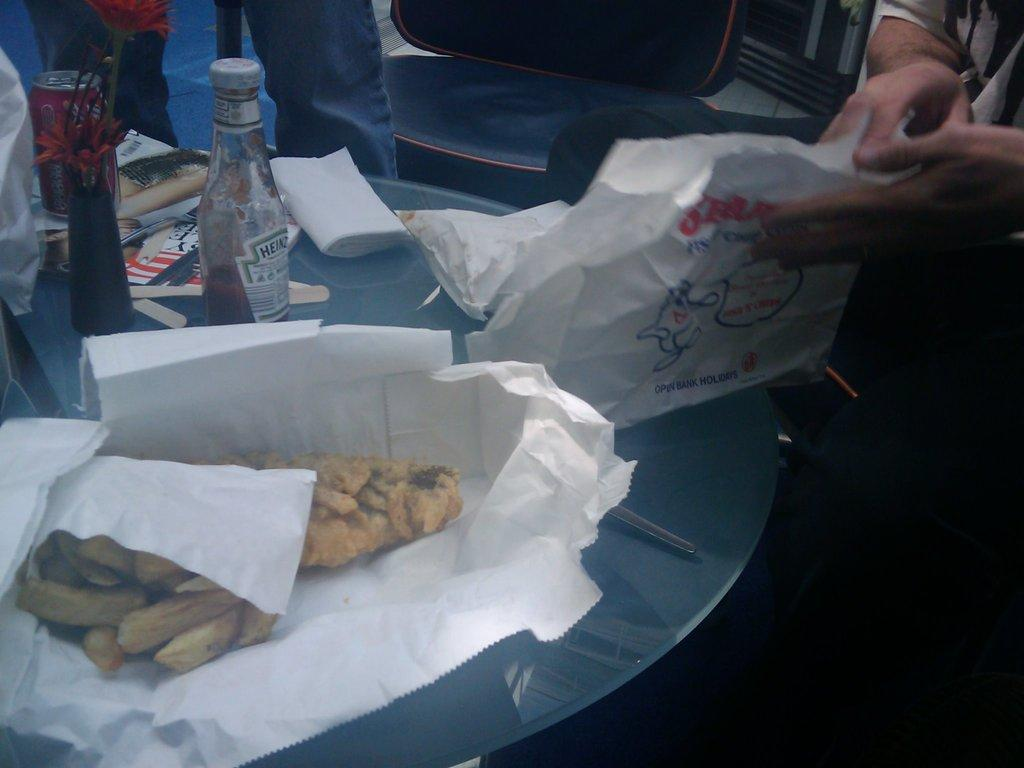What is on the table in the image? There is food on the table, which is wrapped in paper. What else can be seen on the table besides the food? There is a bottle, a tin, and tissues present on the table. Are there any utensils or tools visible in the image? The presence of human hands suggests that someone might be using utensils or tools, but they are not directly visible in the image. What type of wall can be seen in the background of the image? There is no wall visible in the image; it only shows items on a table. 